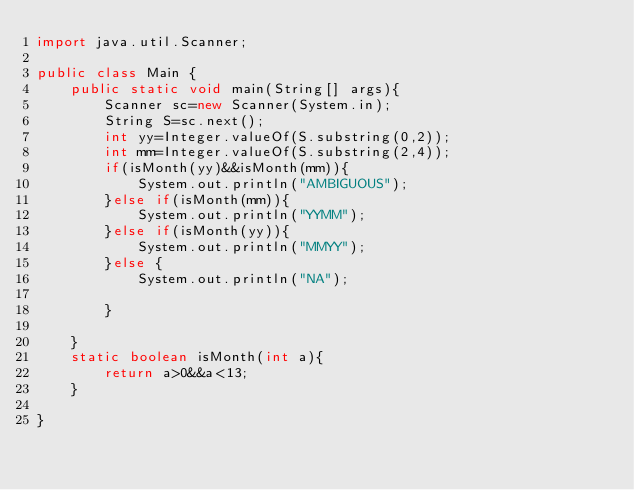<code> <loc_0><loc_0><loc_500><loc_500><_Java_>import java.util.Scanner;

public class Main {
    public static void main(String[] args){
        Scanner sc=new Scanner(System.in);
        String S=sc.next();
        int yy=Integer.valueOf(S.substring(0,2));
        int mm=Integer.valueOf(S.substring(2,4));
        if(isMonth(yy)&&isMonth(mm)){
            System.out.println("AMBIGUOUS");
        }else if(isMonth(mm)){
            System.out.println("YYMM");
        }else if(isMonth(yy)){
            System.out.println("MMYY");
        }else {
            System.out.println("NA");

        }

    }
    static boolean isMonth(int a){
        return a>0&&a<13;
    }

}
</code> 